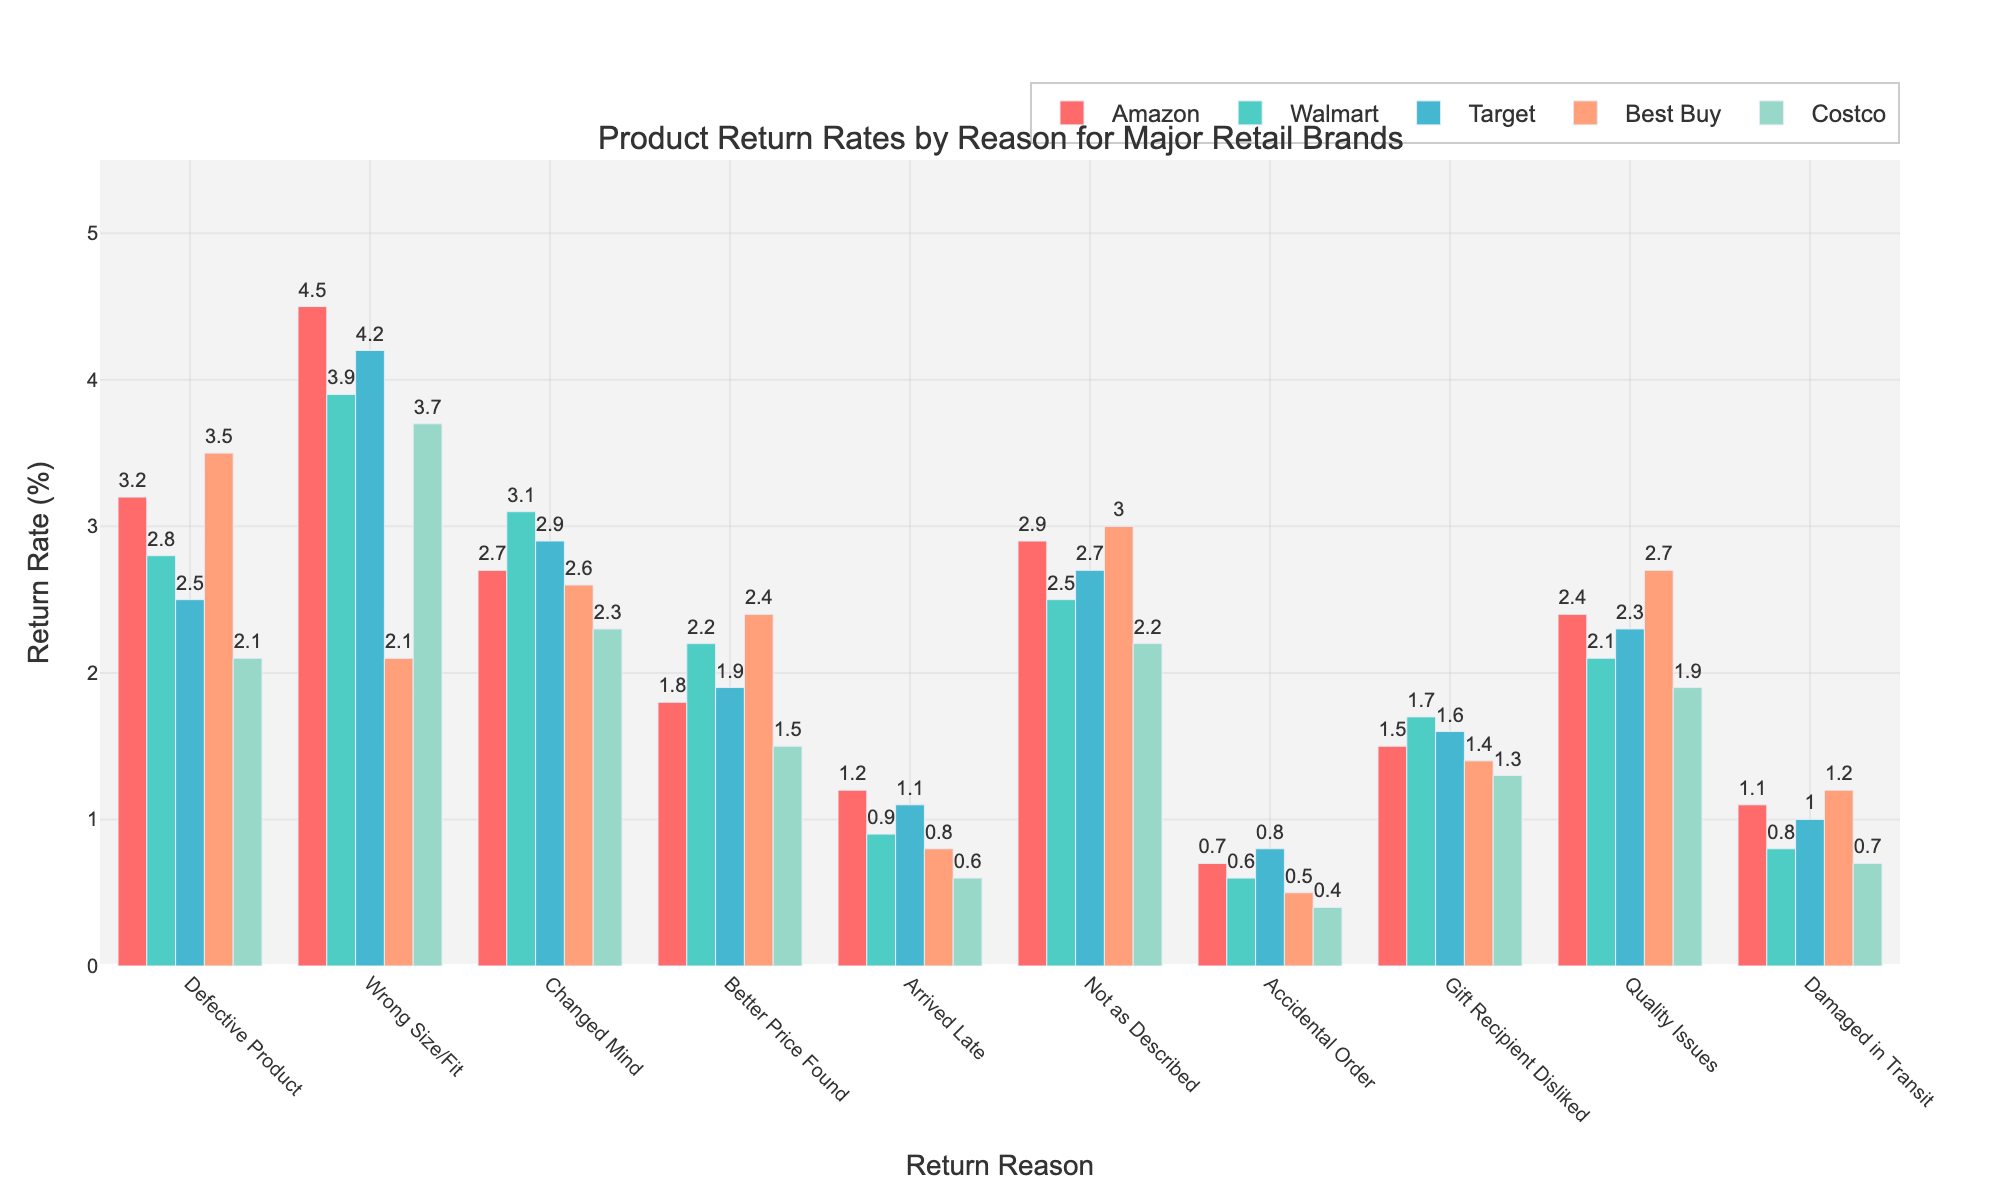what is the highest return rate for Amazon and for which reason? To answer this, look for the highest bar amongst those representing Amazon. The highest bar for Amazon corresponds to the "Wrong Size/Fit" with a return rate of 4.5%.
Answer: 4.5%, Wrong Size/Fit which retailer has the lowest return rate for the reason "Accidental Order"? Identify the bar for "Accidental Order" for all retailers and compare their heights. The lowest bar for "Accidental Order" is for Costco at 0.4%.
Answer: Costco, 0.4% what is the overall average return rate of Walmart across all reasons? To find the average, sum up the return rates of Walmart across all reasons and divide by the number of reasons (10). Sum is (2.8 + 3.9 + 3.1 + 2.2 + 0.9 + 2.5 + 0.6 + 1.7 + 2.1 + 0.8) = 20.6. So the average is 20.6/10 = 2.06.
Answer: 2.06% which reason has a higher return rate for Best Buy: "Defective Product" or "Quality Issues"? Compare the bars for Best Buy under "Defective Product" and "Quality Issues." The bar under "Defective Product" is 3.5 and for "Quality Issues" is 2.7.
Answer: Defective Product, 3.5% between Target and Amazon, which has a higher return rate for the reason "Arrived Late"? Compare the bars for "Arrived Late" between Target and Amazon. Amazon has 1.2% and Target has 1.1%.
Answer: Amazon, 1.2% what is the total return rate for Costco for the reasons "Changed Mind" and "Damaged in Transit"? Add the return rates of Costco for "Changed Mind" and "Damaged in Transit". The return rates are 2.3 and 0.7 respectively. Sum is 2.3 + 0.7 = 3.0
Answer: 3.0% how much greater is the return rate for "Better Price Found" for Best Buy compared to Costco? Subtract the return rate of Costco from Best Buy for "Better Price Found". Best Buy is 2.4 and Costco is 1.5. Difference is 2.4 - 1.5 = 0.9.
Answer: 0.9 which retailer has the highest return rate for the reason "Gift Recipient Disliked"? Identify the tallest bar for "Gift Recipient Disliked" across all retailers. Walmart has the highest return rate of 1.7%.
Answer: Walmart, 1.7% what is the combined return rate for all retailers for the reason "Defective Product"? Sum the return rates of all retailers for "Defective Product". The rates are 3.2, 2.8, 2.5, 3.5, and 2.1. Sum is 3.2 + 2.8 + 2.5 + 3.5 + 2.1 = 14.1
Answer: 14.1 what is the difference in return rate for "Not as Described" between Amazon and Best Buy? Subtract the return rate of Amazon from Best Buy for "Not as Described". Best Buy is 3.0 and Amazon is 2.9. Difference is 3.0 - 2.9 = 0.1.
Answer: 0.1 